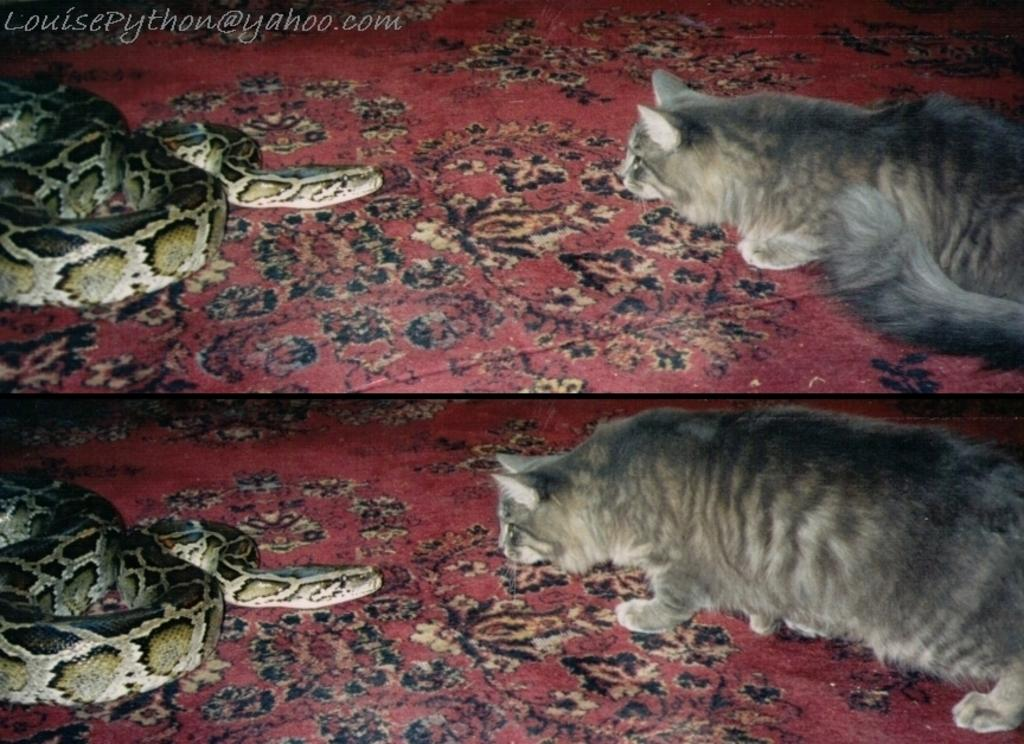What type of artwork is depicted in the image? The image is a collage. What animals are on the left side of the collage? There are snakes on the left side of the image. What animals are on the right side of the collage? There are cats on the right side of the image. What type of food is at the bottom of the collage? There are red meats at the bottom of the image. What type of tin can be seen in the image? There is no tin present in the image. How many cards are visible in the image? There are no cards visible in the image. 